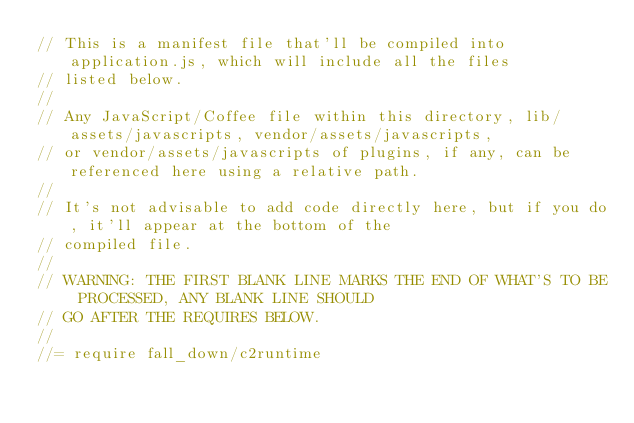Convert code to text. <code><loc_0><loc_0><loc_500><loc_500><_JavaScript_>// This is a manifest file that'll be compiled into application.js, which will include all the files
// listed below.
//
// Any JavaScript/Coffee file within this directory, lib/assets/javascripts, vendor/assets/javascripts,
// or vendor/assets/javascripts of plugins, if any, can be referenced here using a relative path.
//
// It's not advisable to add code directly here, but if you do, it'll appear at the bottom of the
// compiled file.
//
// WARNING: THE FIRST BLANK LINE MARKS THE END OF WHAT'S TO BE PROCESSED, ANY BLANK LINE SHOULD
// GO AFTER THE REQUIRES BELOW.
//
//= require fall_down/c2runtime</code> 